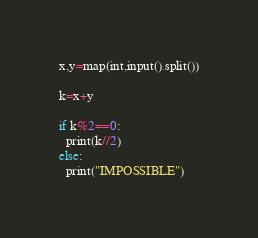Convert code to text. <code><loc_0><loc_0><loc_500><loc_500><_Python_>x,y=map(int,input().split())

k=x+y

if k%2==0:
  print(k//2)
else:
  print("IMPOSSIBLE")</code> 